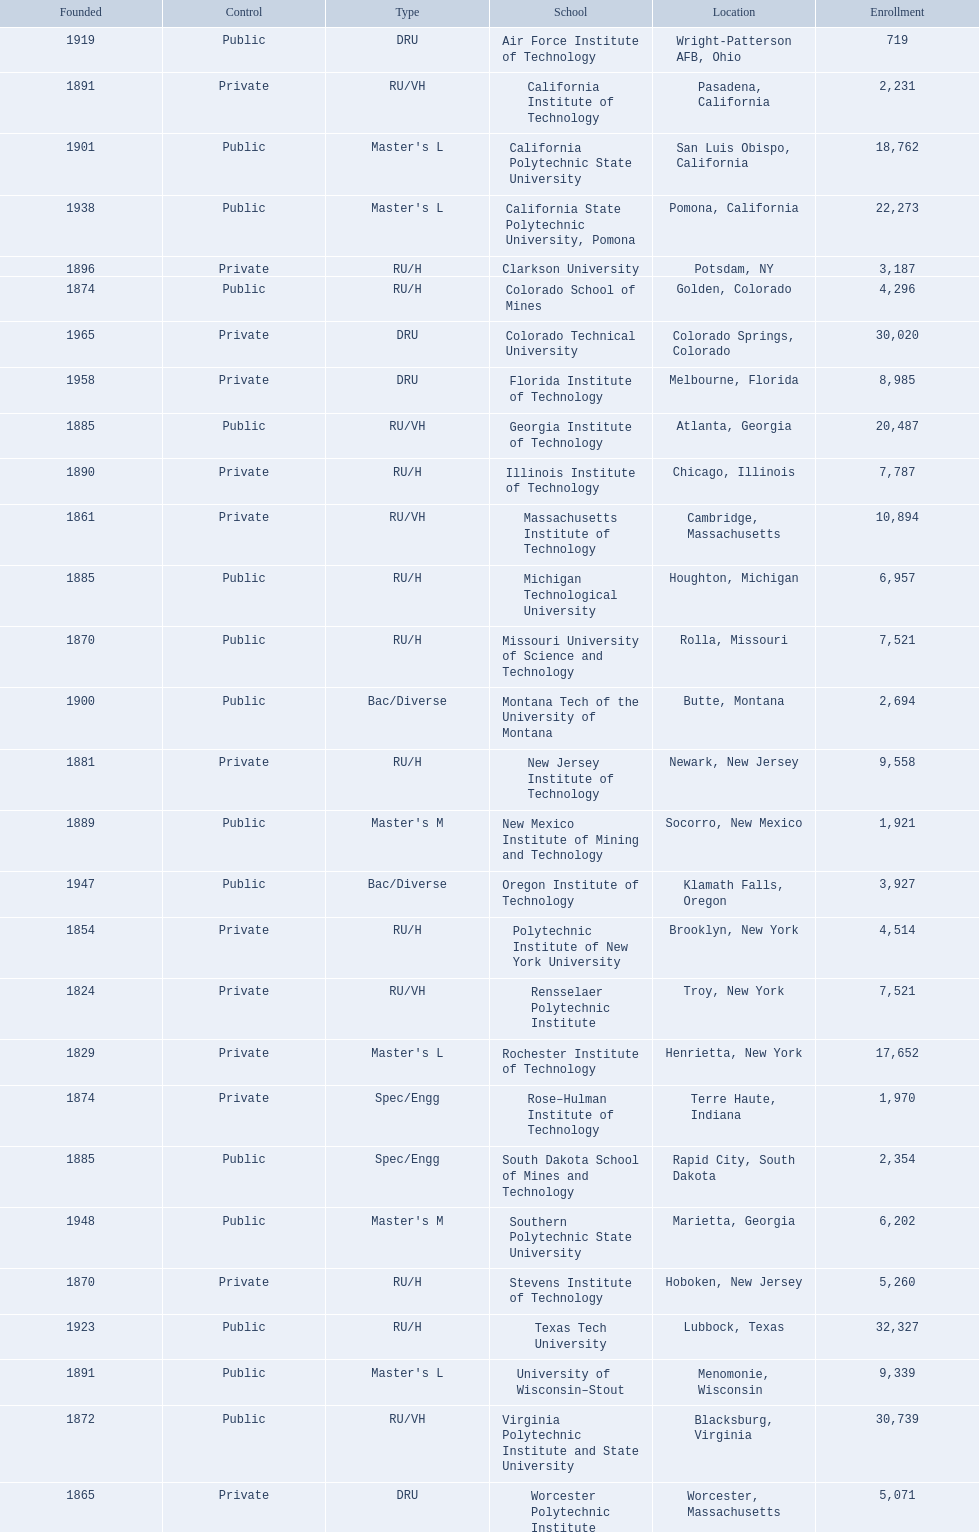What technical universities are in the united states? Air Force Institute of Technology, California Institute of Technology, California Polytechnic State University, California State Polytechnic University, Pomona, Clarkson University, Colorado School of Mines, Colorado Technical University, Florida Institute of Technology, Georgia Institute of Technology, Illinois Institute of Technology, Massachusetts Institute of Technology, Michigan Technological University, Missouri University of Science and Technology, Montana Tech of the University of Montana, New Jersey Institute of Technology, New Mexico Institute of Mining and Technology, Oregon Institute of Technology, Polytechnic Institute of New York University, Rensselaer Polytechnic Institute, Rochester Institute of Technology, Rose–Hulman Institute of Technology, South Dakota School of Mines and Technology, Southern Polytechnic State University, Stevens Institute of Technology, Texas Tech University, University of Wisconsin–Stout, Virginia Polytechnic Institute and State University, Worcester Polytechnic Institute. Which has the highest enrollment? Texas Tech University. 